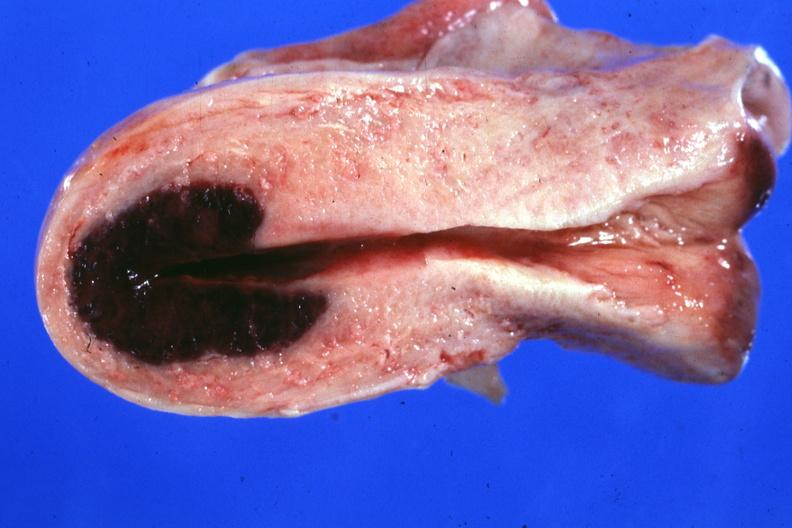what is localized lesion in dome of uterus said?
Answer the question using a single word or phrase. To have adenosis adenomyosis hemorrhage probably due to shock 